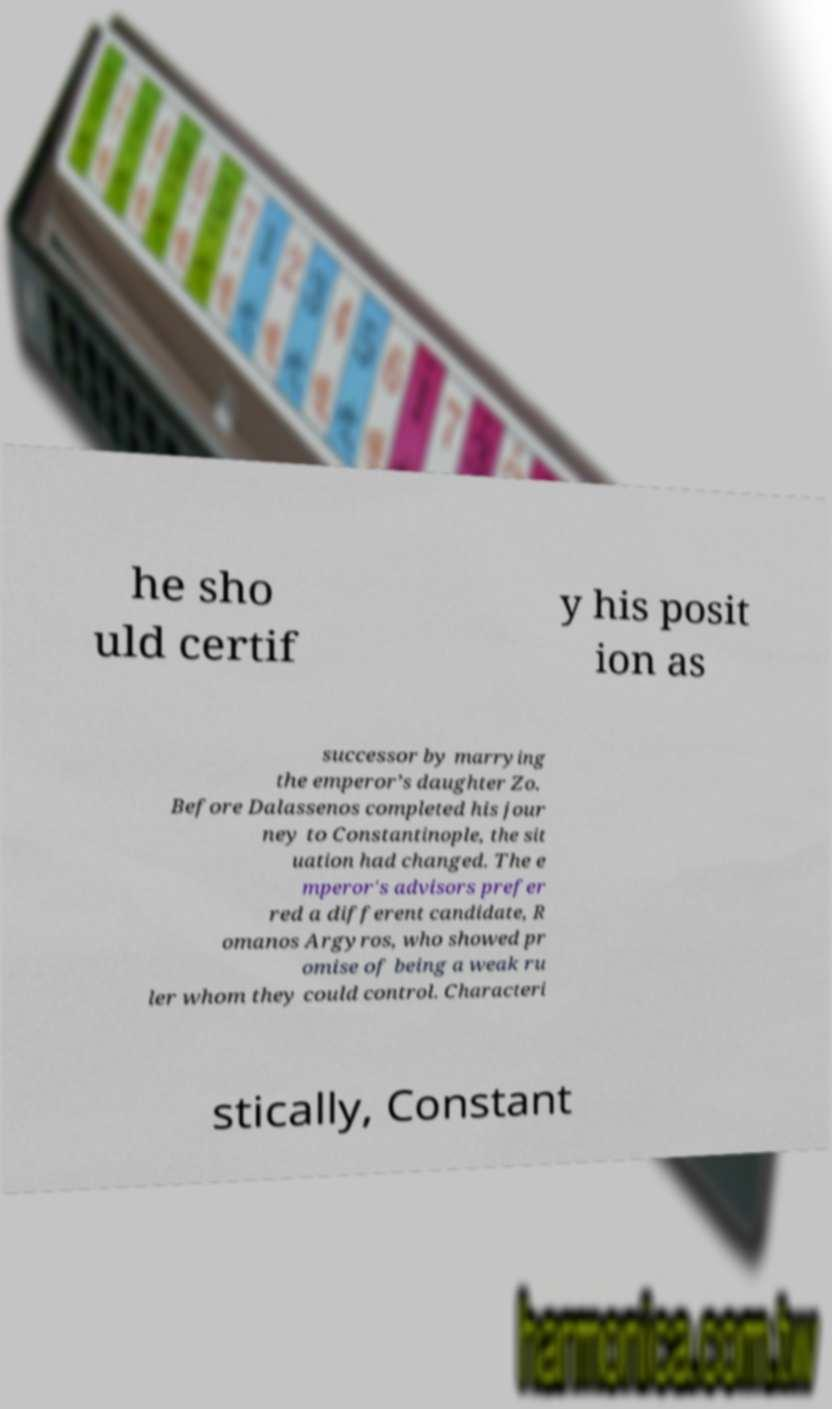For documentation purposes, I need the text within this image transcribed. Could you provide that? he sho uld certif y his posit ion as successor by marrying the emperor’s daughter Zo. Before Dalassenos completed his jour ney to Constantinople, the sit uation had changed. The e mperor's advisors prefer red a different candidate, R omanos Argyros, who showed pr omise of being a weak ru ler whom they could control. Characteri stically, Constant 